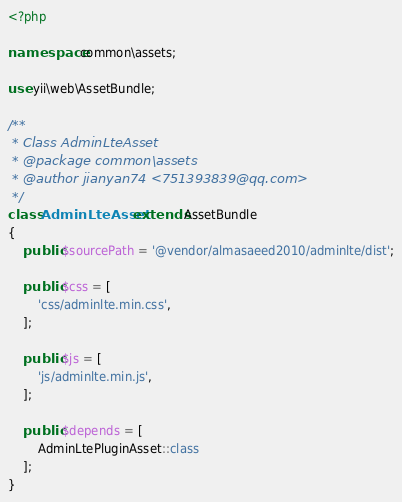<code> <loc_0><loc_0><loc_500><loc_500><_PHP_><?php

namespace common\assets;

use yii\web\AssetBundle;

/**
 * Class AdminLteAsset
 * @package common\assets
 * @author jianyan74 <751393839@qq.com>
 */
class AdminLteAsset extends AssetBundle
{
    public $sourcePath = '@vendor/almasaeed2010/adminlte/dist';

    public $css = [
        'css/adminlte.min.css',
    ];

    public $js = [
        'js/adminlte.min.js',
    ];

    public $depends = [
        AdminLtePluginAsset::class
    ];
}
</code> 